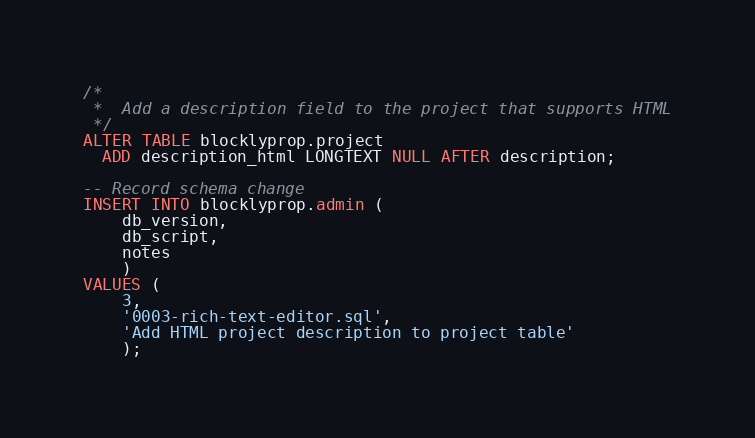<code> <loc_0><loc_0><loc_500><loc_500><_SQL_>/*
 *  Add a description field to the project that supports HTML
 */
ALTER TABLE blocklyprop.project
  ADD description_html LONGTEXT NULL AFTER description;

-- Record schema change
INSERT INTO blocklyprop.admin (
    db_version, 
    db_script,
    notes
    )
VALUES (
    3,
    '0003-rich-text-editor.sql',
    'Add HTML project description to project table'
    );
</code> 